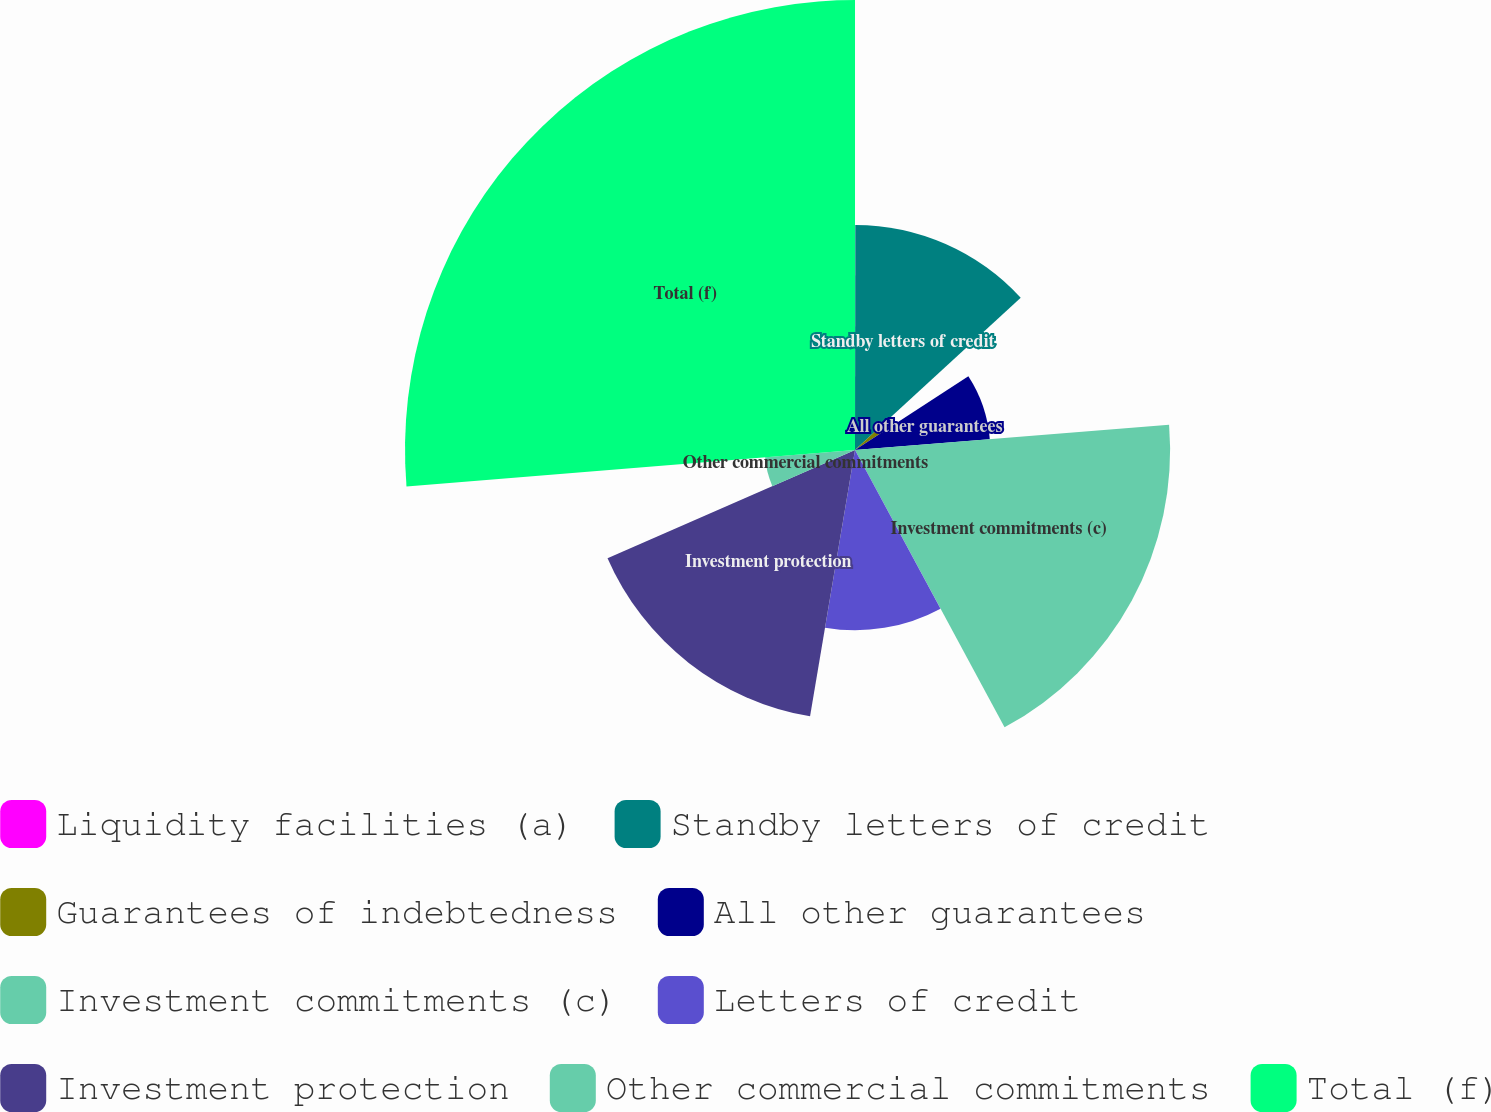<chart> <loc_0><loc_0><loc_500><loc_500><pie_chart><fcel>Liquidity facilities (a)<fcel>Standby letters of credit<fcel>Guarantees of indebtedness<fcel>All other guarantees<fcel>Investment commitments (c)<fcel>Letters of credit<fcel>Investment protection<fcel>Other commercial commitments<fcel>Total (f)<nl><fcel>0.02%<fcel>13.15%<fcel>2.65%<fcel>7.9%<fcel>18.41%<fcel>10.53%<fcel>15.78%<fcel>5.27%<fcel>26.29%<nl></chart> 